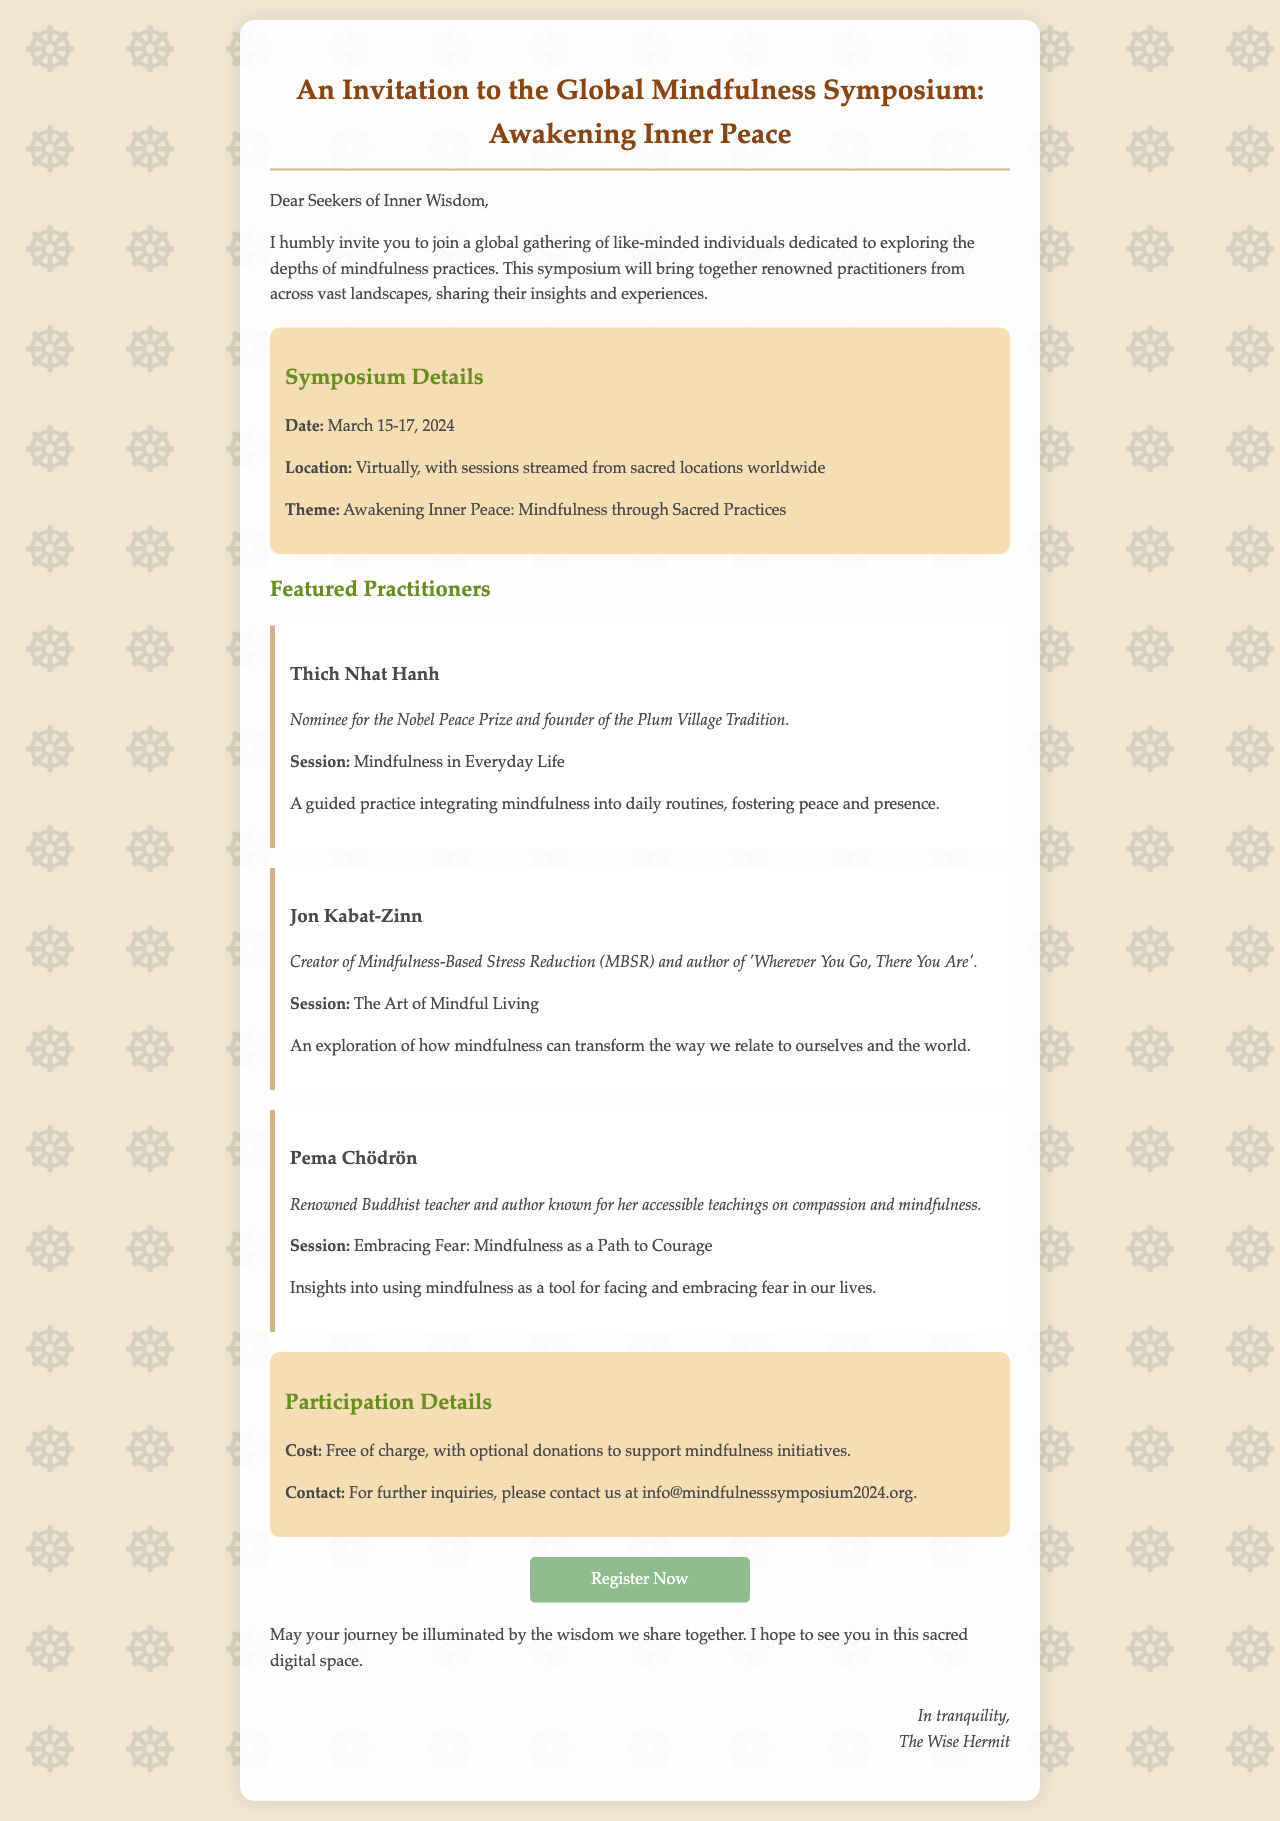What are the dates of the symposium? The document specifies that the symposium will take place on March 15-17, 2024.
Answer: March 15-17, 2024 What is the theme of the symposium? The theme is provided as "Awakening Inner Peace: Mindfulness through Sacred Practices."
Answer: Awakening Inner Peace: Mindfulness through Sacred Practices Who is the first featured practitioner? The document lists Thich Nhat Hanh as the first featured practitioner.
Answer: Thich Nhat Hanh What is the cost to participate in the symposium? The document states that participation is free of charge.
Answer: Free of charge What type of event is this document inviting readers to? The invitation pertains specifically to a digital symposium focused on mindfulness practices.
Answer: Digital symposium What session does Jon Kabat-Zinn lead? The document indicates that Jon Kabat-Zinn will lead the session titled "The Art of Mindful Living."
Answer: The Art of Mindful Living How can participants register for the symposium? The document provides a link for registration as "http://www.mindfulnesssymposium2024.org/register."
Answer: http://www.mindfulnesssymposium2024.org/register Who can be contacted for further inquiries? The document lists the contact email as info@mindfulnesssymposium2024.org.
Answer: info@mindfulnesssymposium2024.org 